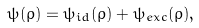Convert formula to latex. <formula><loc_0><loc_0><loc_500><loc_500>\psi ( \rho ) = \psi _ { i d } ( \rho ) + \psi _ { e x c } ( \rho ) ,</formula> 